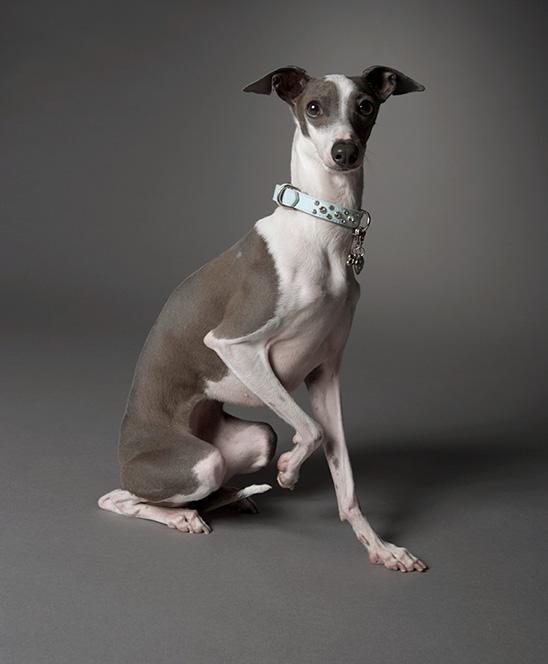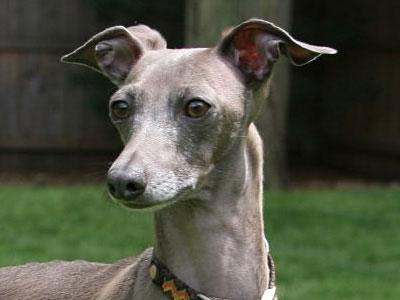The first image is the image on the left, the second image is the image on the right. Assess this claim about the two images: "A dog is standing on all four legs with it's full body visible.". Correct or not? Answer yes or no. No. 